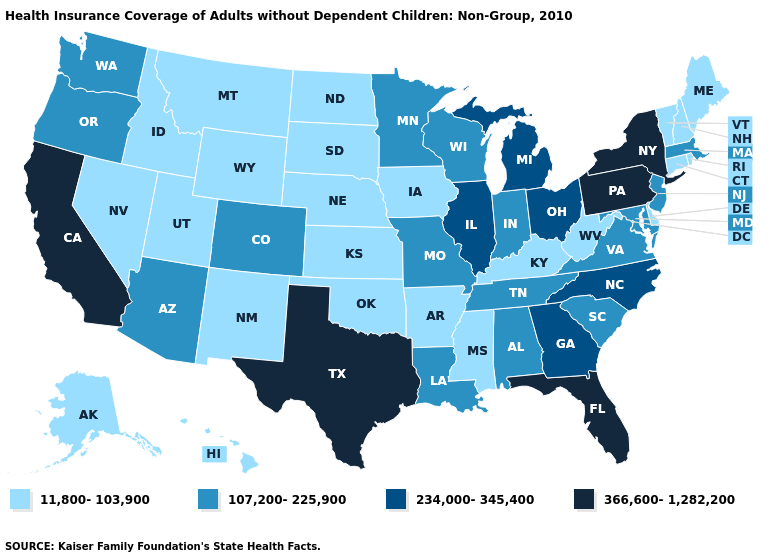Does the first symbol in the legend represent the smallest category?
Concise answer only. Yes. Among the states that border Mississippi , which have the lowest value?
Write a very short answer. Arkansas. Among the states that border Iowa , does Missouri have the highest value?
Concise answer only. No. What is the highest value in the USA?
Write a very short answer. 366,600-1,282,200. What is the highest value in the USA?
Quick response, please. 366,600-1,282,200. Does Ohio have the highest value in the MidWest?
Concise answer only. Yes. Name the states that have a value in the range 107,200-225,900?
Give a very brief answer. Alabama, Arizona, Colorado, Indiana, Louisiana, Maryland, Massachusetts, Minnesota, Missouri, New Jersey, Oregon, South Carolina, Tennessee, Virginia, Washington, Wisconsin. Name the states that have a value in the range 107,200-225,900?
Quick response, please. Alabama, Arizona, Colorado, Indiana, Louisiana, Maryland, Massachusetts, Minnesota, Missouri, New Jersey, Oregon, South Carolina, Tennessee, Virginia, Washington, Wisconsin. Name the states that have a value in the range 366,600-1,282,200?
Write a very short answer. California, Florida, New York, Pennsylvania, Texas. Which states have the highest value in the USA?
Keep it brief. California, Florida, New York, Pennsylvania, Texas. Name the states that have a value in the range 234,000-345,400?
Keep it brief. Georgia, Illinois, Michigan, North Carolina, Ohio. Does Texas have the highest value in the South?
Keep it brief. Yes. What is the value of Vermont?
Write a very short answer. 11,800-103,900. What is the value of Kentucky?
Be succinct. 11,800-103,900. 